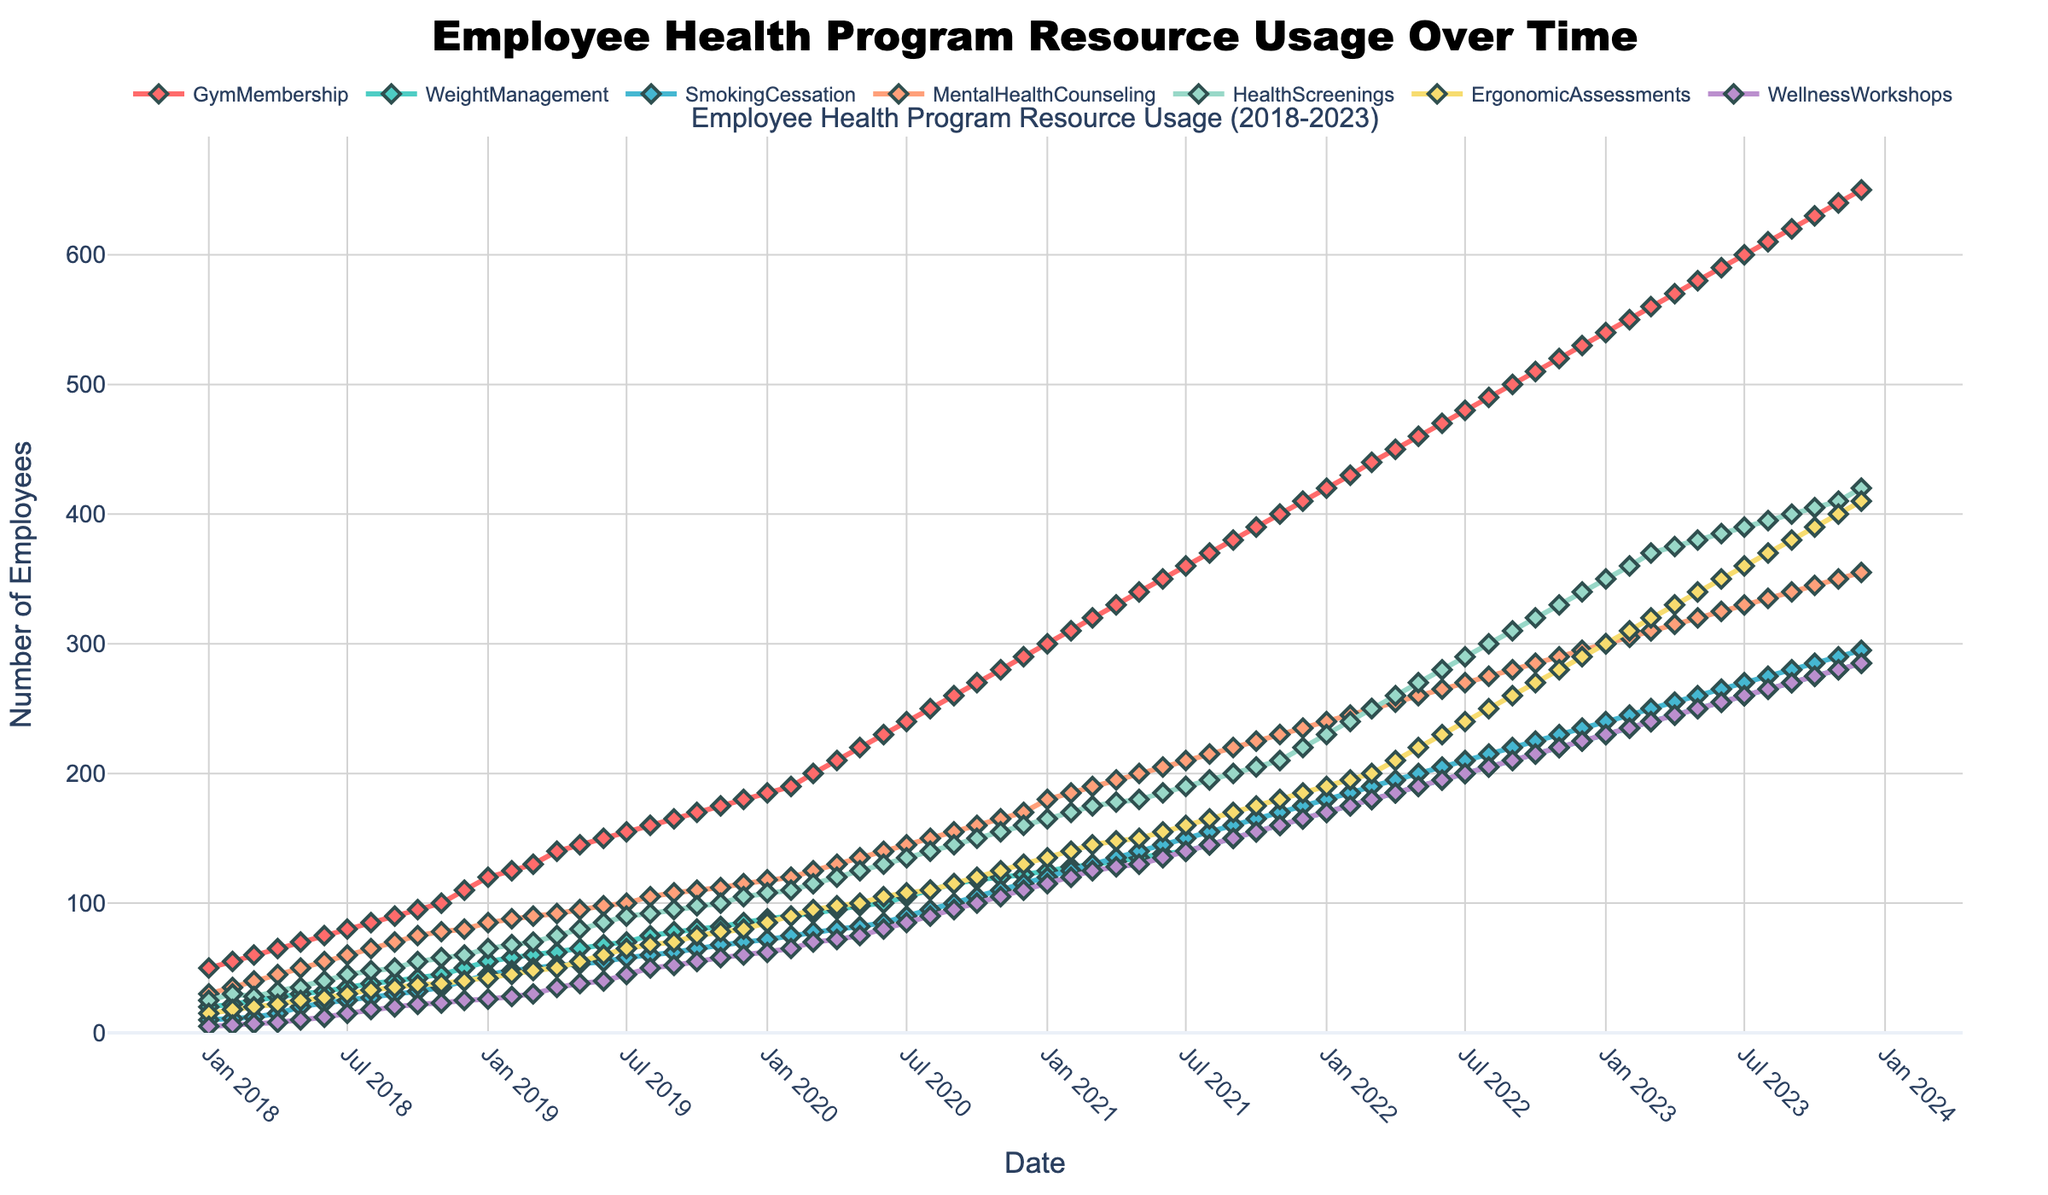What is the title of the plot? The title of the plot is located at the top and provides a summary of what the plot represents. Here it is "Employee Health Program Resource Usage Over Time".
Answer: Employee Health Program Resource Usage Over Time How many different categories of employee health program resources are tracked in this plot? The plot includes multiple lines, each representing a different category of employee health program resources. Counting these categories gives us the total number.
Answer: 7 What color represents the "Gym Membership" category? In the legend, each category is represented with a specific color. The line for "Gym Membership" is colored red.
Answer: Red Which month and year saw the highest number of employees using the "Mental Health Counseling" resource? To find the highest usage, look at the peak point on the line representing "Mental Health Counseling" and check the corresponding month and year on the x-axis.
Answer: December 2023 What is the total number of employees using the "Weight Management" and "Smoking Cessation" resources in June 2021? Check the plot for the values corresponding to June 2021 for both categories and add them up. The values are 138 for Weight Management and 145 for Smoking Cessation. Summing these, 138 + 145 equals 283.
Answer: 283 By how much did the use of "Health Screenings" resources change from January 2019 to December 2019? Look at the value of Health Screenings in January 2019 and December 2019, and calculate the difference between these values. January 2019 is 65 and December 2019 is 105, so the change is 105 - 65 = 40.
Answer: 40 Which resource experienced the most consistent growth over the time period shown? Consistent growth can be seen in a steadily increasing line without significant drops. Review the lines for each resource and identify which one shows this pattern clearly. "Gym Membership" shows consistent, steady growth.
Answer: Gym Membership How did the usage of "Wellness Workshops" in December 2022 compare to December 2021? Locate the values on the plot for December 2021 and December 2022 for Wellness Workshops. They are 165 in December 2021 and 225 in December 2022. Compare these values to see the difference, 225 - 165 = 60.
Answer: 60 more in December 2022 Which category had the least usage in September 2018? Check the values of each category for September 2018 and determine which one is the lowest. "Wellness Workshops" has the lowest value of 20.
Answer: Wellness Workshops What trend do you see in the usage of "Ergonomic Assessments" from January 2020 to December 2020? Analyze the segment of the line from January 2020 to December 2020 for Ergonomic Assessments. There is a clear upward trend, indicating increased usage over the year.
Answer: Increasing trend 